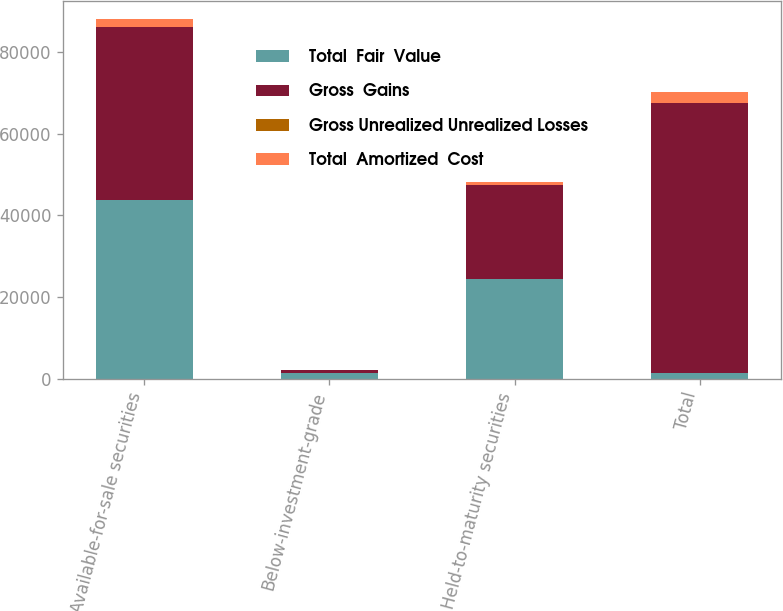<chart> <loc_0><loc_0><loc_500><loc_500><stacked_bar_chart><ecel><fcel>Available-for-sale securities<fcel>Below-investment-grade<fcel>Held-to-maturity securities<fcel>Total<nl><fcel>Total  Fair  Value<fcel>43834<fcel>1274<fcel>24436<fcel>1274<nl><fcel>Gross  Gains<fcel>42273<fcel>786<fcel>23084<fcel>66143<nl><fcel>Gross Unrealized Unrealized Losses<fcel>63.9<fcel>1.2<fcel>34.9<fcel>100<nl><fcel>Total  Amortized  Cost<fcel>2038<fcel>6<fcel>571<fcel>2615<nl></chart> 